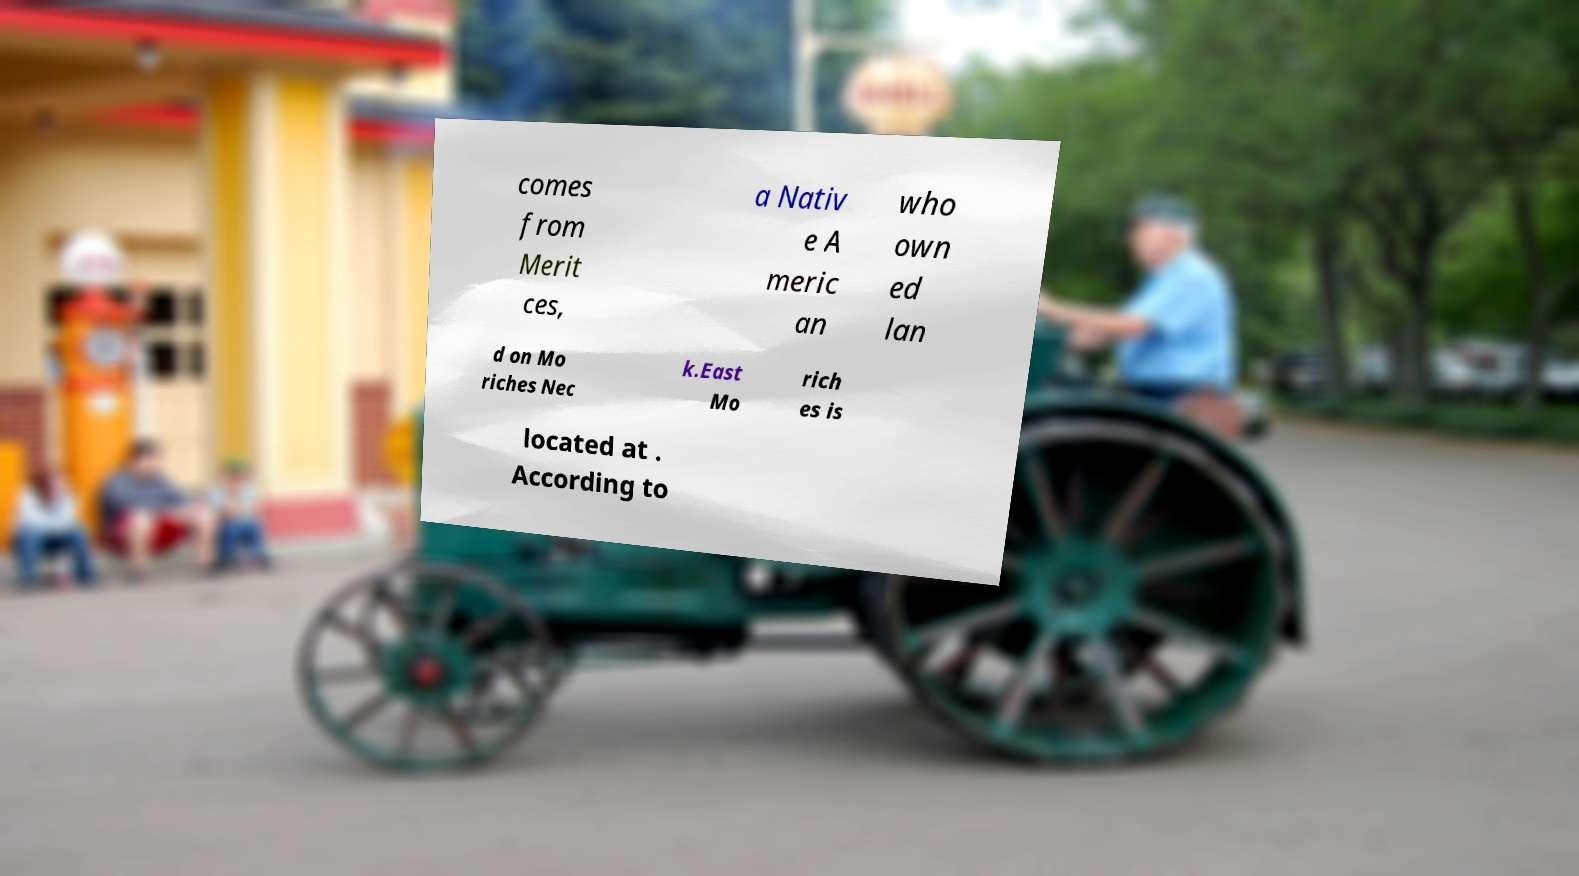Could you assist in decoding the text presented in this image and type it out clearly? comes from Merit ces, a Nativ e A meric an who own ed lan d on Mo riches Nec k.East Mo rich es is located at . According to 